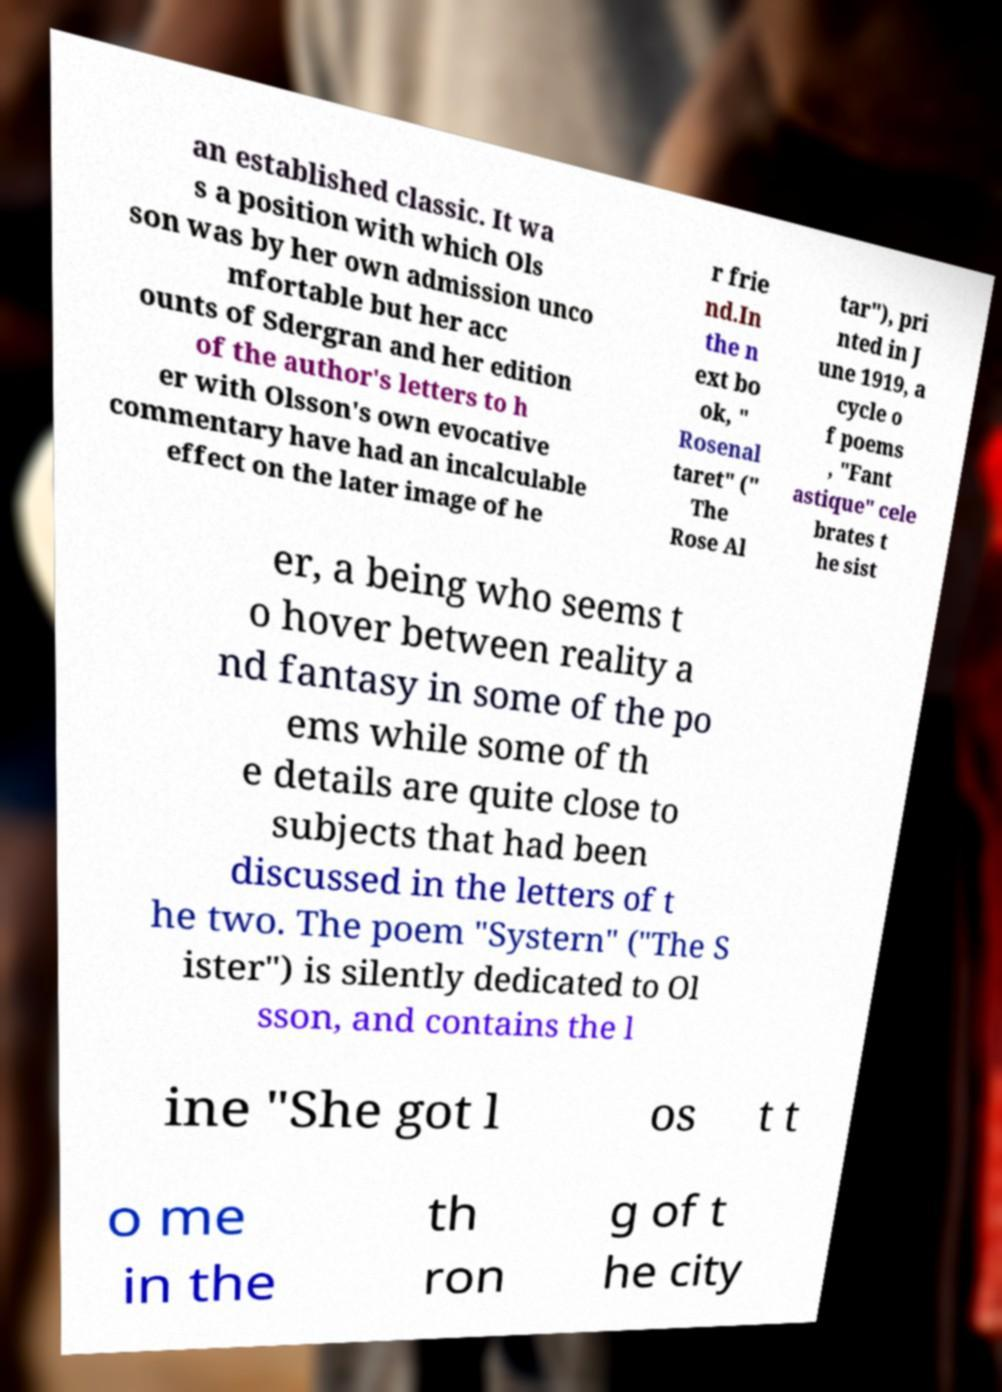Please read and relay the text visible in this image. What does it say? an established classic. It wa s a position with which Ols son was by her own admission unco mfortable but her acc ounts of Sdergran and her edition of the author's letters to h er with Olsson's own evocative commentary have had an incalculable effect on the later image of he r frie nd.In the n ext bo ok, " Rosenal taret" (" The Rose Al tar"), pri nted in J une 1919, a cycle o f poems , "Fant astique" cele brates t he sist er, a being who seems t o hover between reality a nd fantasy in some of the po ems while some of th e details are quite close to subjects that had been discussed in the letters of t he two. The poem "Systern" ("The S ister") is silently dedicated to Ol sson, and contains the l ine "She got l os t t o me in the th ron g of t he city 